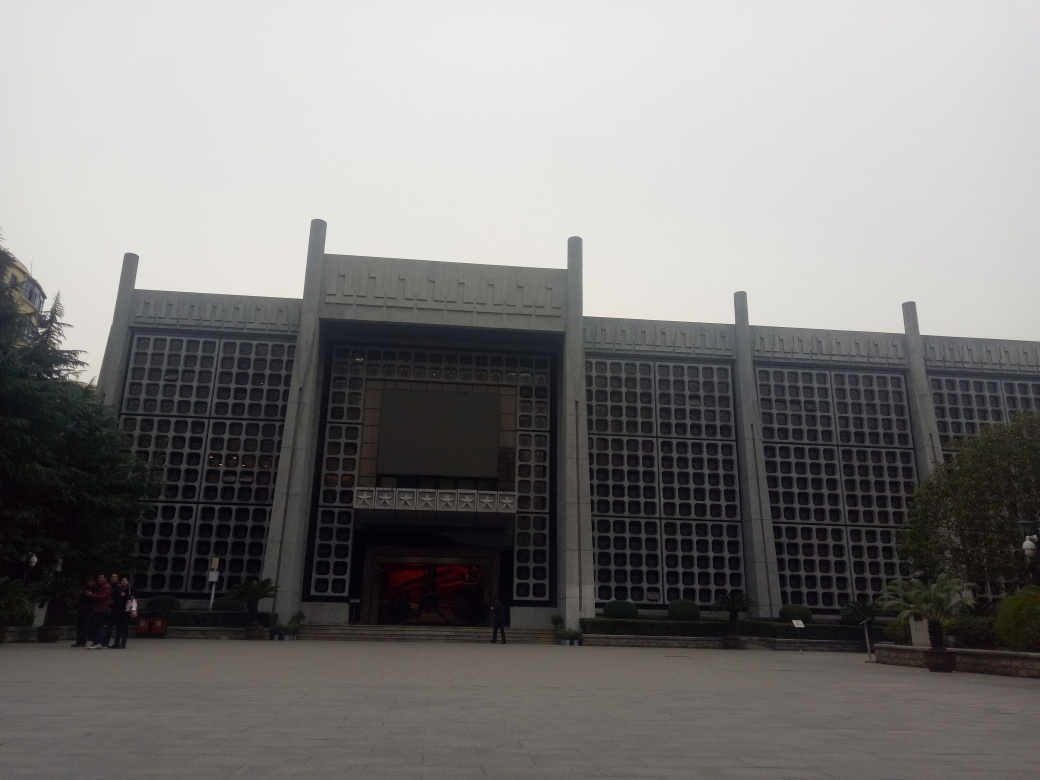What architectural style does this building represent? The building exhibits characteristics of Brutalist architecture, notable for its massive or monolithic appearance and the extensive use of poured concrete or brickwork. It demonstrates a functional approach with a focus on materials, textures, and construction, often resulting in geometric, block-like structures. Can you tell me about the patterns on the building's facade? The patterns on the facade are repetitive geometric shapes, reminiscent of certain mid-20th century architectural motifs. They contribute to an aesthetic that is both decorative and structural, perhaps serving to break the monotony of the large concrete surfaces and giving the building a distinct identity. 